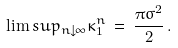<formula> <loc_0><loc_0><loc_500><loc_500>\lim s u p _ { n \downarrow \infty } \kappa ^ { n } _ { 1 } \, = \, \frac { \pi \sigma ^ { 2 } } { 2 } \, .</formula> 